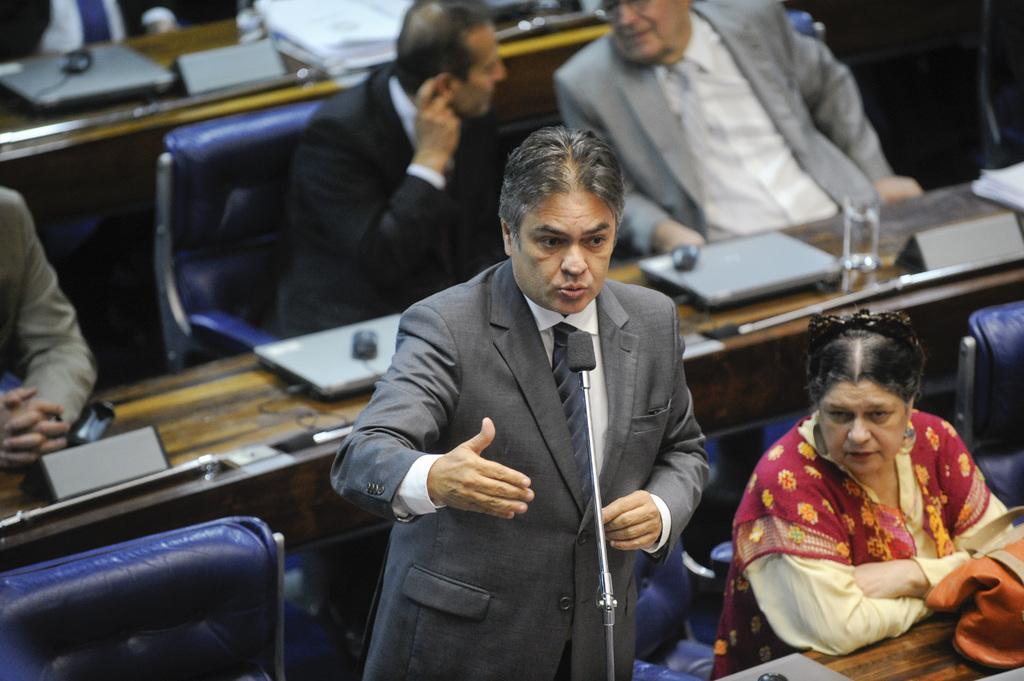Please provide a concise description of this image. There is one man standing at the bottom of this image. We can see people sitting on the chairs in the background. There are laptops and other objects are kept on the tables. 